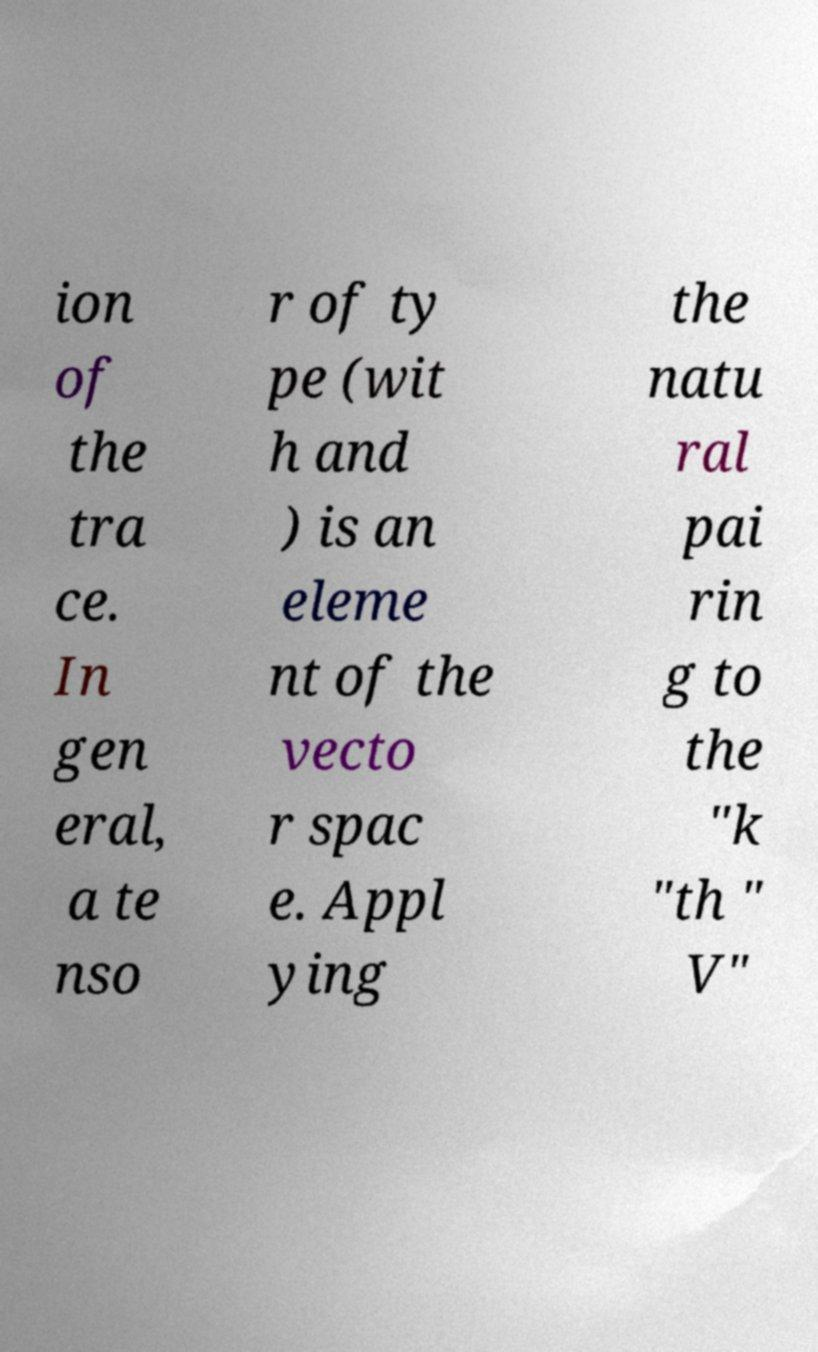Could you assist in decoding the text presented in this image and type it out clearly? ion of the tra ce. In gen eral, a te nso r of ty pe (wit h and ) is an eleme nt of the vecto r spac e. Appl ying the natu ral pai rin g to the "k "th " V" 